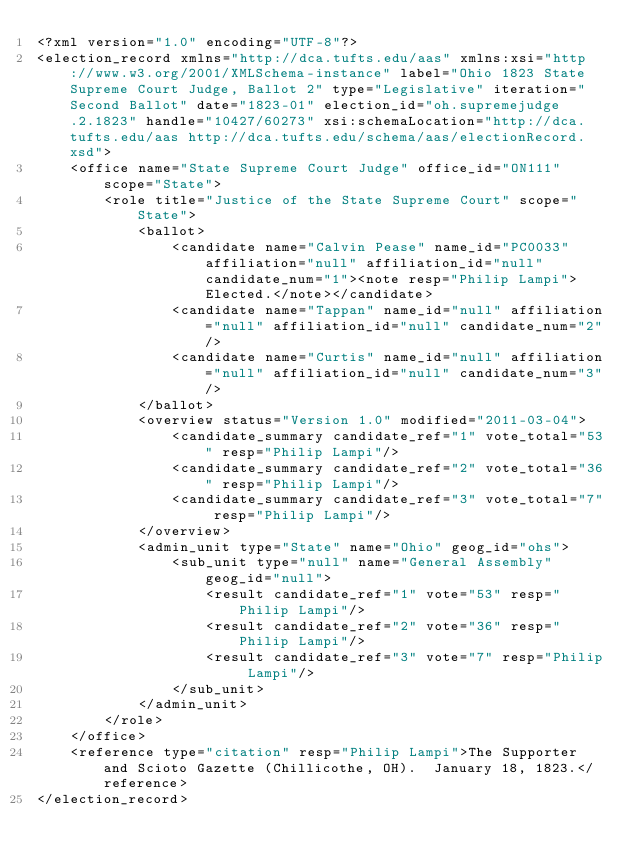<code> <loc_0><loc_0><loc_500><loc_500><_XML_><?xml version="1.0" encoding="UTF-8"?>
<election_record xmlns="http://dca.tufts.edu/aas" xmlns:xsi="http://www.w3.org/2001/XMLSchema-instance" label="Ohio 1823 State Supreme Court Judge, Ballot 2" type="Legislative" iteration="Second Ballot" date="1823-01" election_id="oh.supremejudge.2.1823" handle="10427/60273" xsi:schemaLocation="http://dca.tufts.edu/aas http://dca.tufts.edu/schema/aas/electionRecord.xsd">
    <office name="State Supreme Court Judge" office_id="ON111" scope="State">
        <role title="Justice of the State Supreme Court" scope="State">
            <ballot>
                <candidate name="Calvin Pease" name_id="PC0033" affiliation="null" affiliation_id="null" candidate_num="1"><note resp="Philip Lampi">Elected.</note></candidate>
                <candidate name="Tappan" name_id="null" affiliation="null" affiliation_id="null" candidate_num="2"/>
                <candidate name="Curtis" name_id="null" affiliation="null" affiliation_id="null" candidate_num="3"/>
            </ballot>
            <overview status="Version 1.0" modified="2011-03-04">
                <candidate_summary candidate_ref="1" vote_total="53" resp="Philip Lampi"/>
                <candidate_summary candidate_ref="2" vote_total="36" resp="Philip Lampi"/>
                <candidate_summary candidate_ref="3" vote_total="7" resp="Philip Lampi"/>
            </overview>
            <admin_unit type="State" name="Ohio" geog_id="ohs">
                <sub_unit type="null" name="General Assembly" geog_id="null">
                    <result candidate_ref="1" vote="53" resp="Philip Lampi"/>
                    <result candidate_ref="2" vote="36" resp="Philip Lampi"/>
                    <result candidate_ref="3" vote="7" resp="Philip Lampi"/>
                </sub_unit>
            </admin_unit>
        </role>
    </office>
    <reference type="citation" resp="Philip Lampi">The Supporter and Scioto Gazette (Chillicothe, OH).  January 18, 1823.</reference>
</election_record>
</code> 